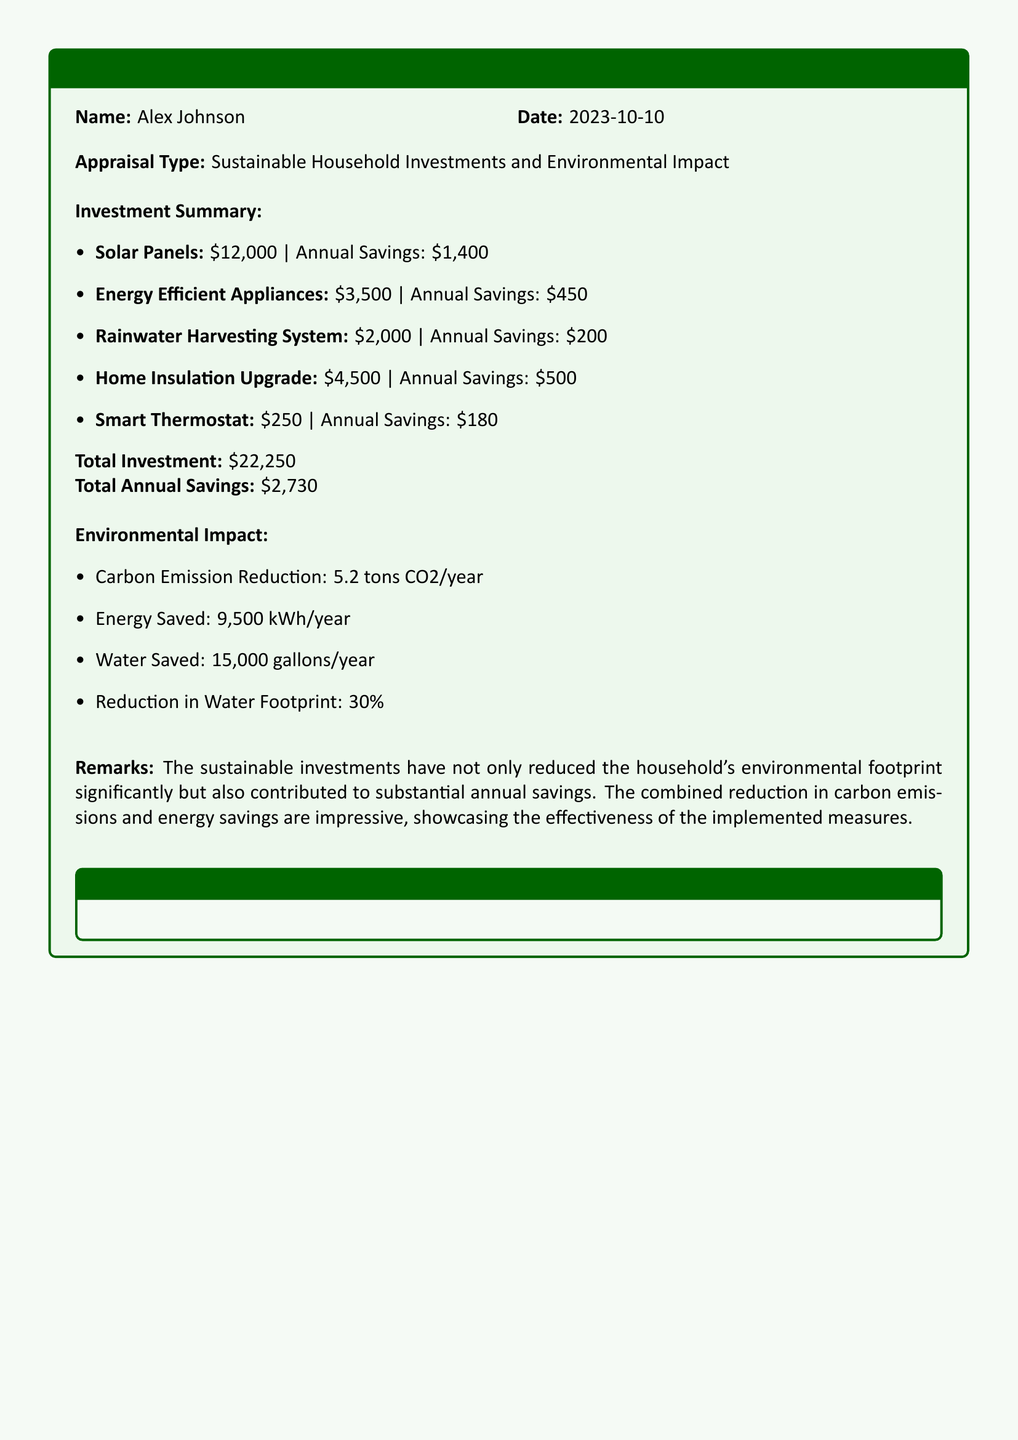What is the date of the appraisal? The date of the appraisal is stated in the document as the date when it was filled out.
Answer: 2023-10-10 What is the total investment amount? The total investment amount can be found in the summary of investments listed in the document.
Answer: $22,250 How much money does the solar panel investment save annually? The annual savings from the solar panel investment is specified in the investment summary section of the document.
Answer: $1,400 What is the total annual savings from all investments? Total annual savings is a calculated figure provided in the summary of the appraisal.
Answer: $2,730 How many tons of CO2 are reduced per year from the home insulation upgrade? This value can be found in the eco-friendly investment breakdown, specifically for home insulation.
Answer: 1.2 tons/year What percentage reduction in the water footprint is achieved? The percentage reduction in the water footprint is explicitly mentioned in the environmental impact section of the document.
Answer: 30% Which investment has the highest upfront cost? The upfront costs of each investment are listed; the one with the highest cost will answer this question.
Answer: Solar Panels How much energy is saved annually by the energy-efficient appliances? The annual energy savings for energy-efficient appliances is indicated in the investment summary.
Answer: 900 kWh/year What is the environmental impact of the rainwater harvesting system? The environmental impact statements summarize the outcomes; information is drawn from the list of savings.
Answer: Water Saved: 15,000 gallons/year 